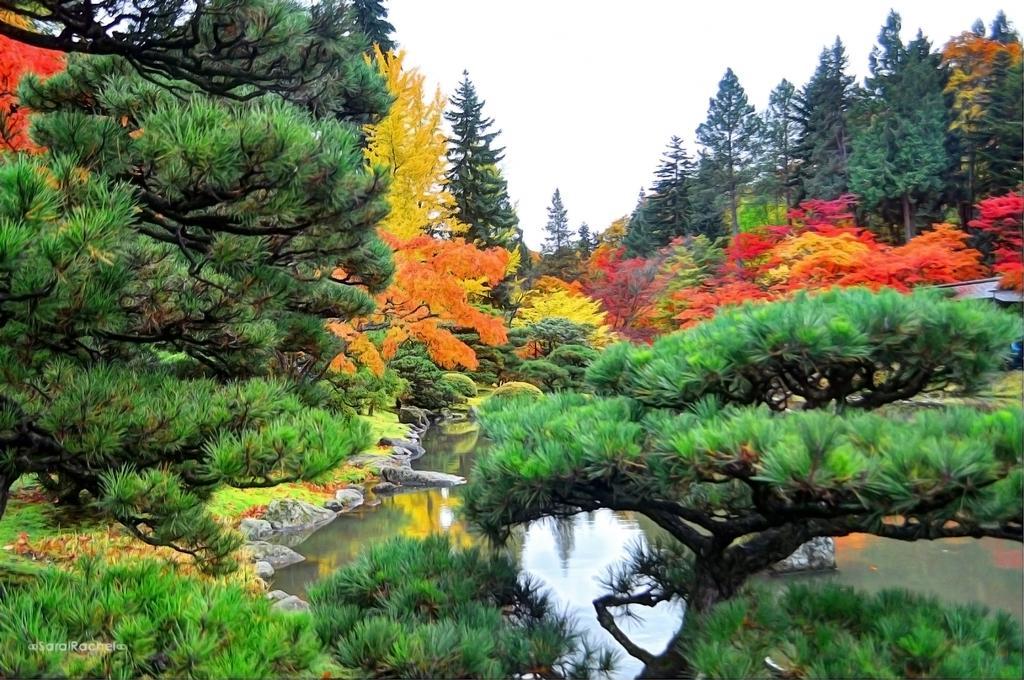In one or two sentences, can you explain what this image depicts? In this image there are trees and we can see water. In the background there is sky. 